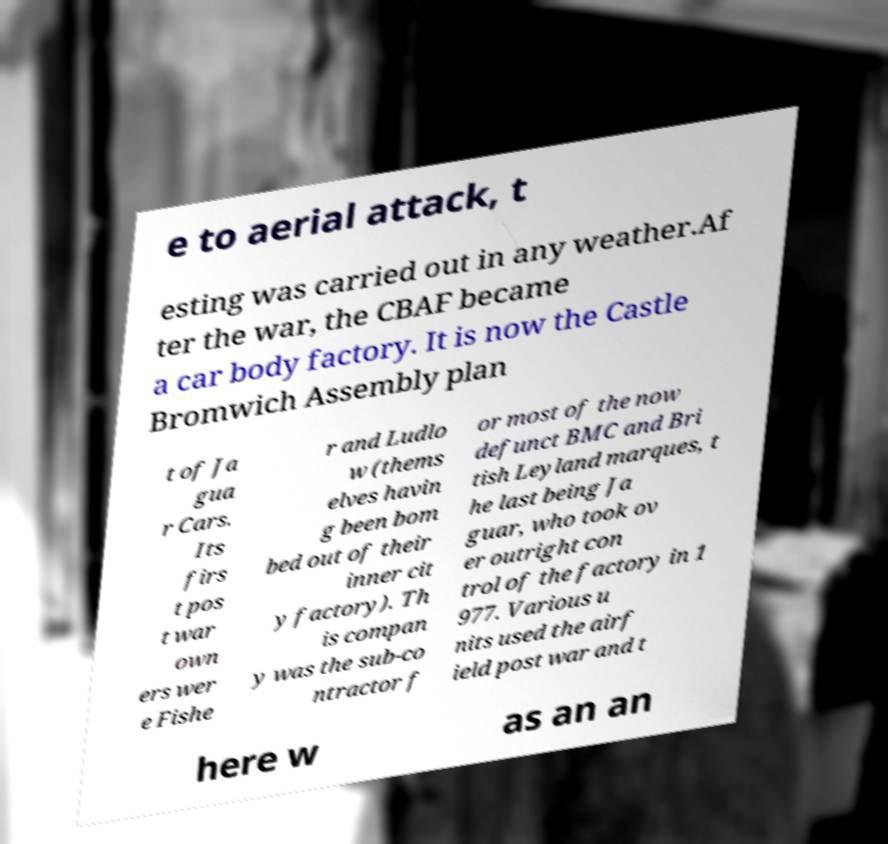I need the written content from this picture converted into text. Can you do that? e to aerial attack, t esting was carried out in any weather.Af ter the war, the CBAF became a car body factory. It is now the Castle Bromwich Assembly plan t of Ja gua r Cars. Its firs t pos t war own ers wer e Fishe r and Ludlo w (thems elves havin g been bom bed out of their inner cit y factory). Th is compan y was the sub-co ntractor f or most of the now defunct BMC and Bri tish Leyland marques, t he last being Ja guar, who took ov er outright con trol of the factory in 1 977. Various u nits used the airf ield post war and t here w as an an 